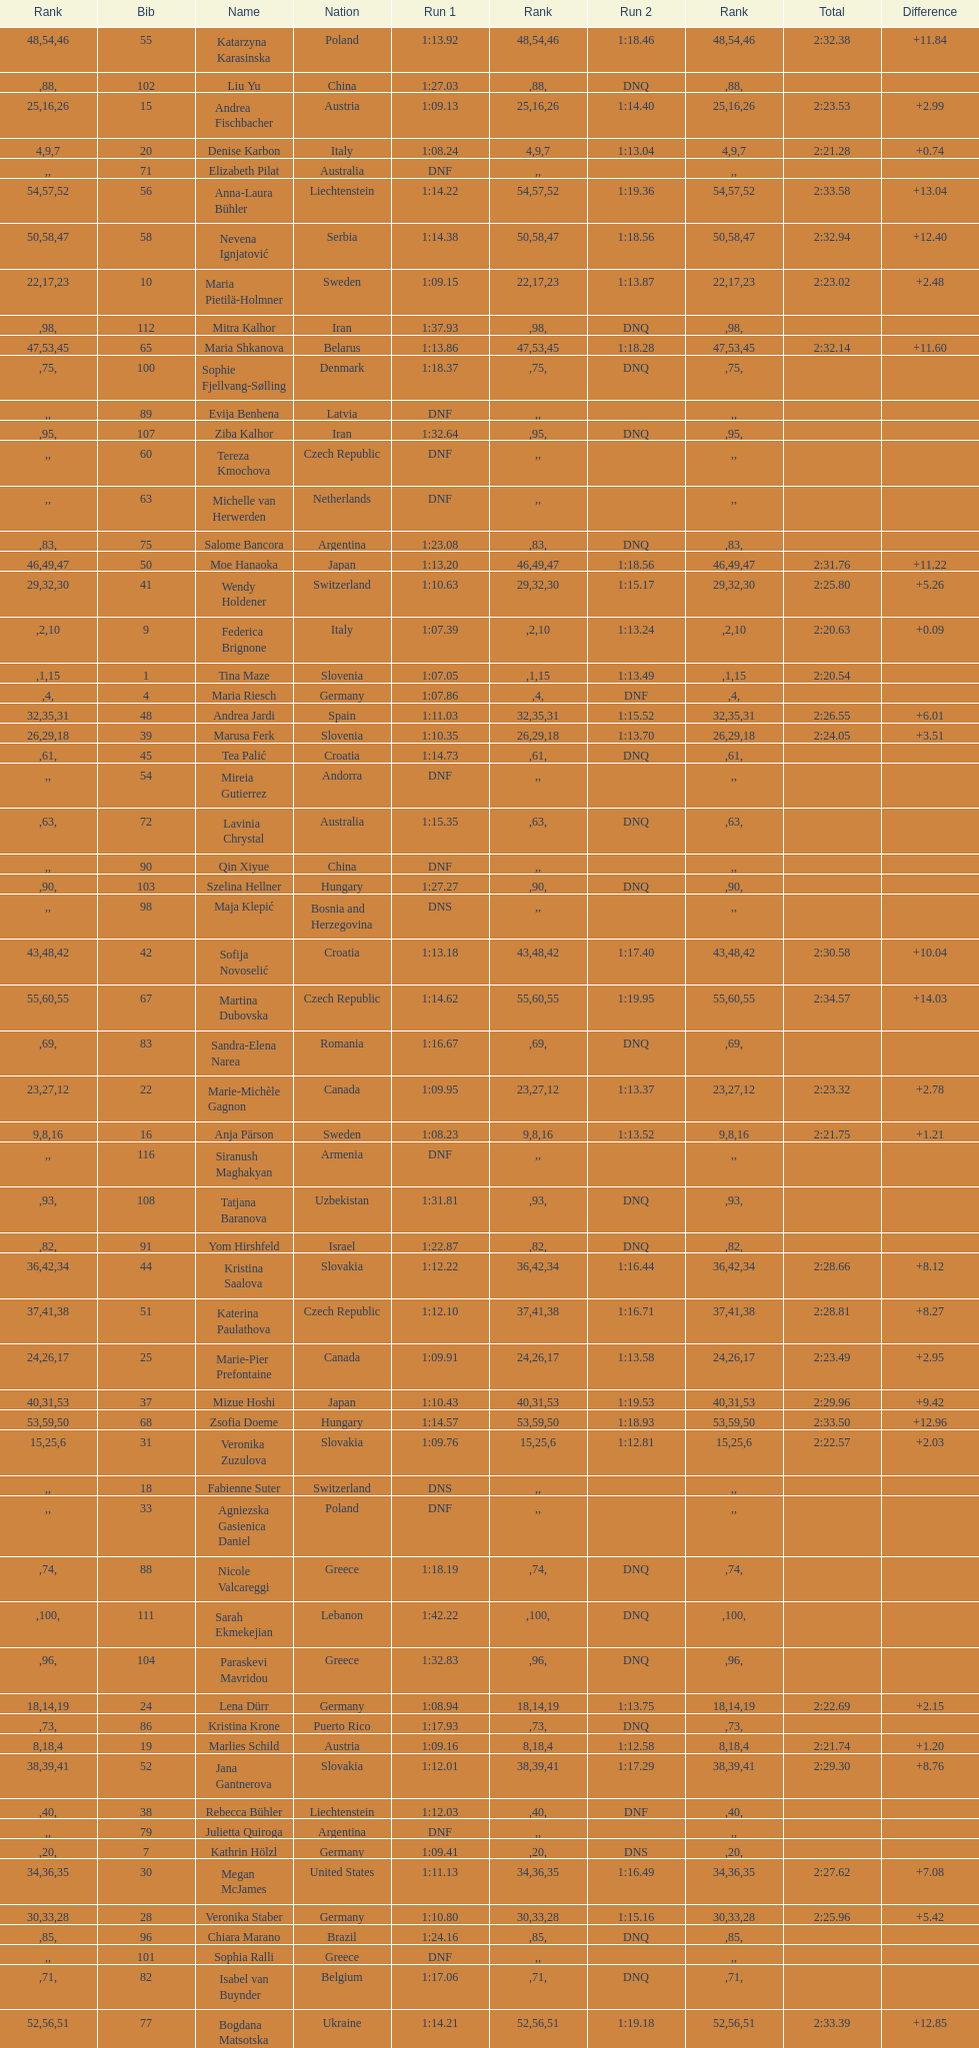What is the last nation to be ranked? Czech Republic. 